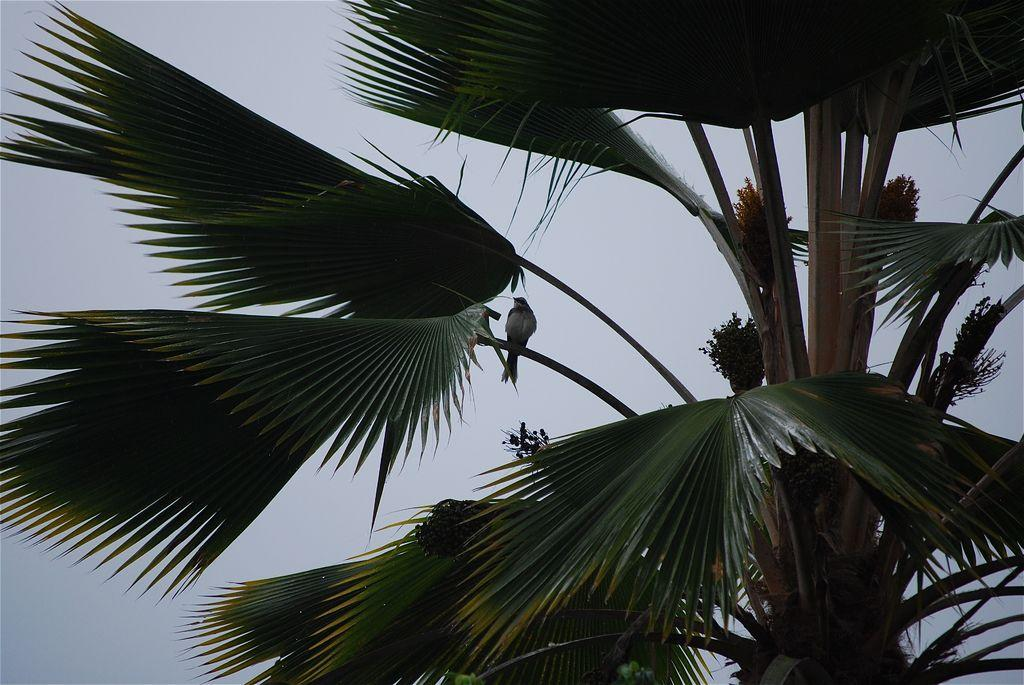What can be seen in the background of the image? The sky is visible in the background of the image. What type of plant is in the image? There is a tree in the image. Can you describe the bird in the image? A bird is present on a branch of the tree. What type of marble is the bird sitting on in the image? There is no marble present in the image; the bird is sitting on a branch of the tree. What is the queen doing in the image? There is no queen present in the image; the image only features a bird on a tree branch and a sky background. 